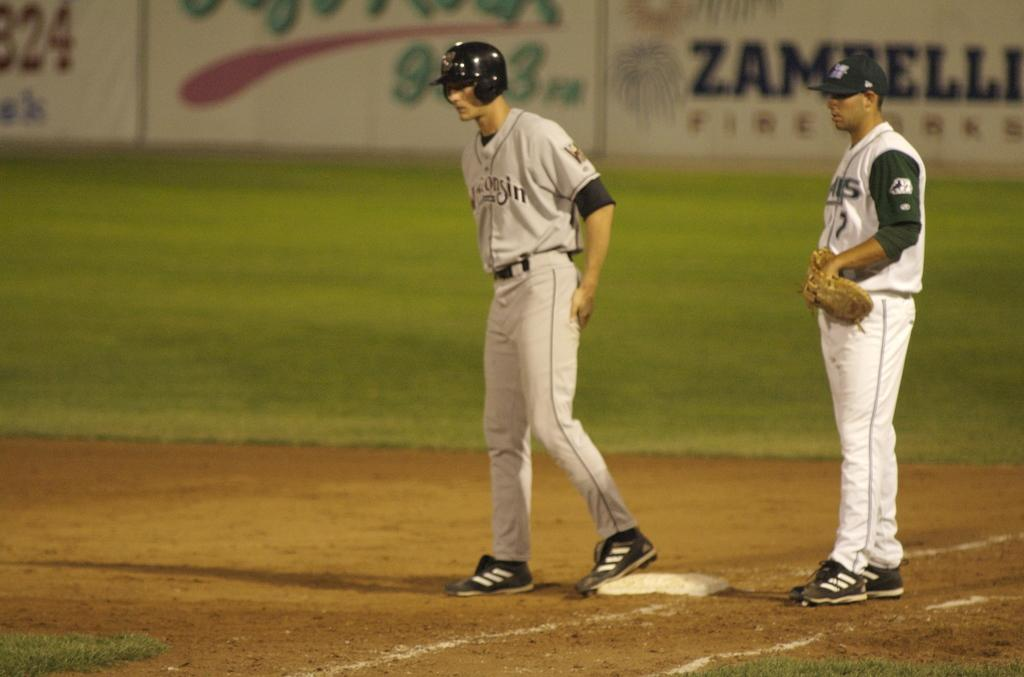<image>
Summarize the visual content of the image. An advert for Zambelli is shown at this baseball pitch. 